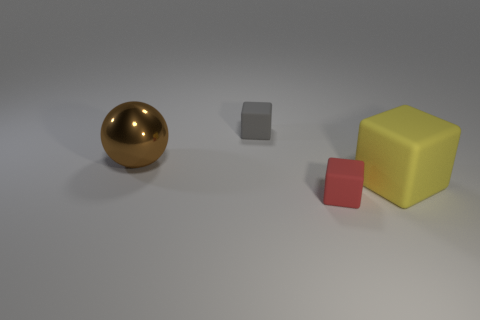How many big spheres are made of the same material as the red thing?
Your response must be concise. 0. There is a large thing that is the same material as the small red thing; what is its color?
Ensure brevity in your answer.  Yellow. What is the size of the object to the left of the cube to the left of the tiny rubber object right of the gray object?
Offer a very short reply. Large. Is the number of red blocks less than the number of large things?
Ensure brevity in your answer.  Yes. The other small object that is the same shape as the small red thing is what color?
Provide a short and direct response. Gray. There is a tiny block behind the rubber thing that is in front of the big yellow block; are there any big spheres that are in front of it?
Your response must be concise. Yes. Is the large brown metallic object the same shape as the small red matte thing?
Your answer should be compact. No. Is the number of large metal spheres to the left of the large shiny thing less than the number of tiny gray cubes?
Ensure brevity in your answer.  Yes. There is a small block that is in front of the big thing on the right side of the tiny object right of the gray thing; what is its color?
Offer a very short reply. Red. How many matte things are either brown spheres or big gray balls?
Offer a terse response. 0. 